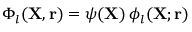Convert formula to latex. <formula><loc_0><loc_0><loc_500><loc_500>\Phi _ { l } ( { X } , { r } ) = \psi ( { X } ) \, \phi _ { l } ( { X } ; { r } )</formula> 